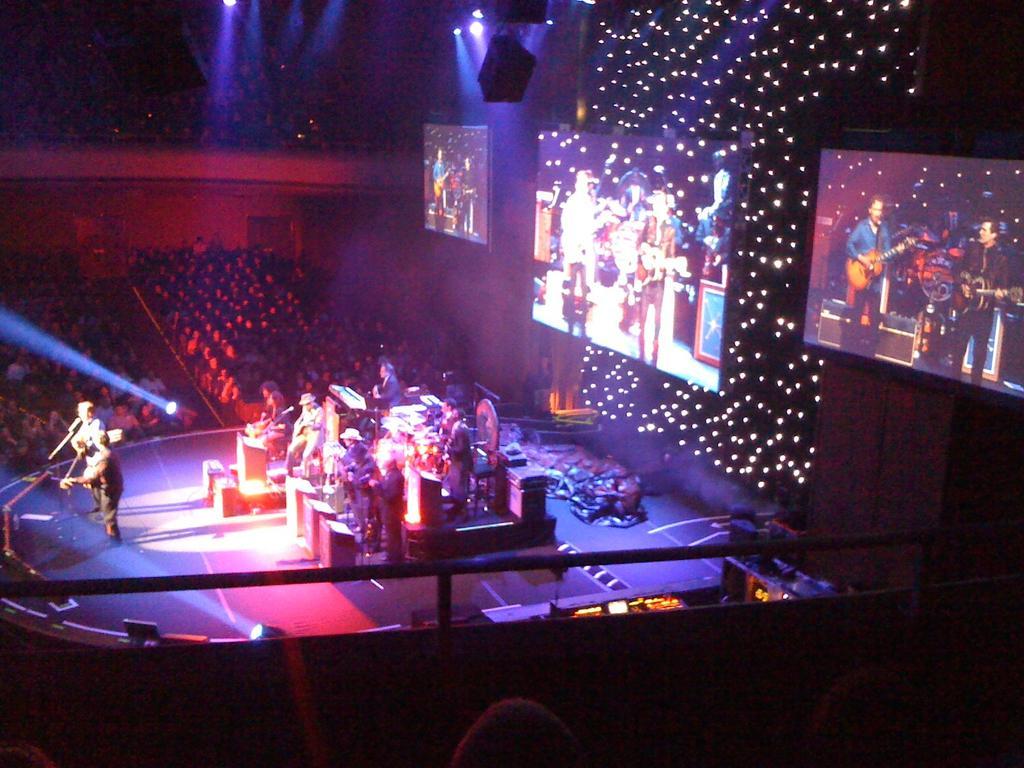In one or two sentences, can you explain what this image depicts? In this picture we can see a few people playing musical instruments on the stage. There are many people visible from left to right. We can see a few screens and lights on top. 